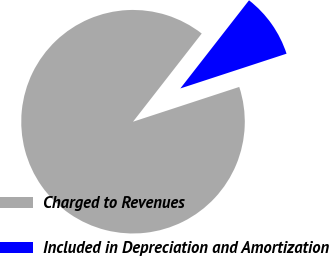<chart> <loc_0><loc_0><loc_500><loc_500><pie_chart><fcel>Charged to Revenues<fcel>Included in Depreciation and Amortization<nl><fcel>90.57%<fcel>9.43%<nl></chart> 